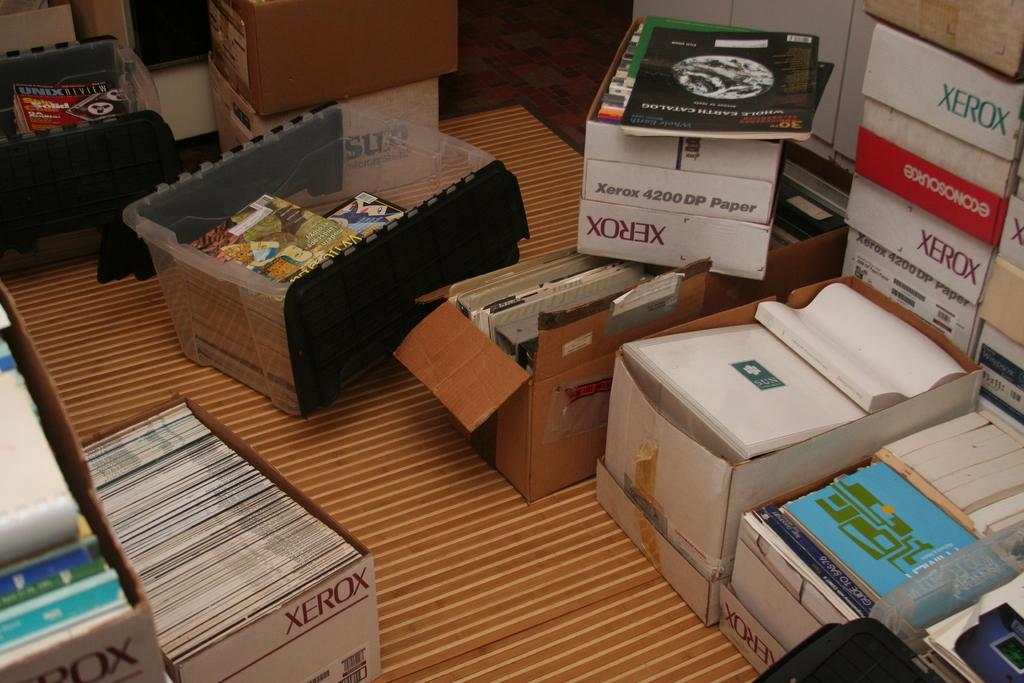<image>
Summarize the visual content of the image. several Xerox boxes are piled around on the floor 